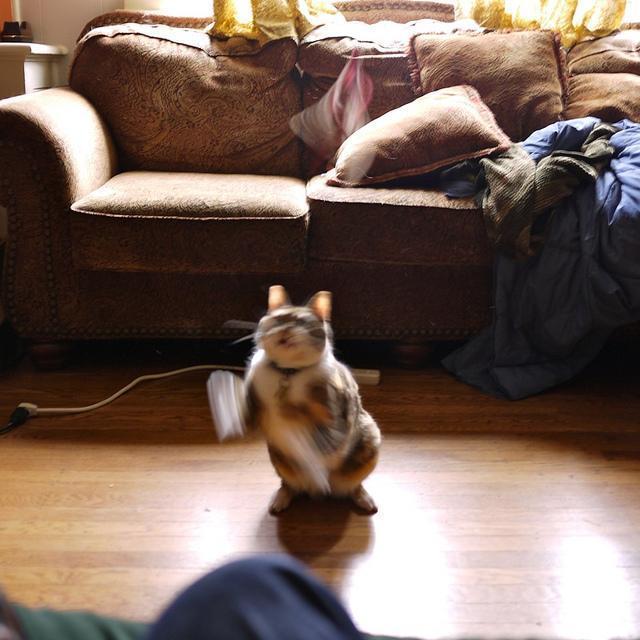Evaluate: Does the caption "The person is on the couch." match the image?
Answer yes or no. No. 